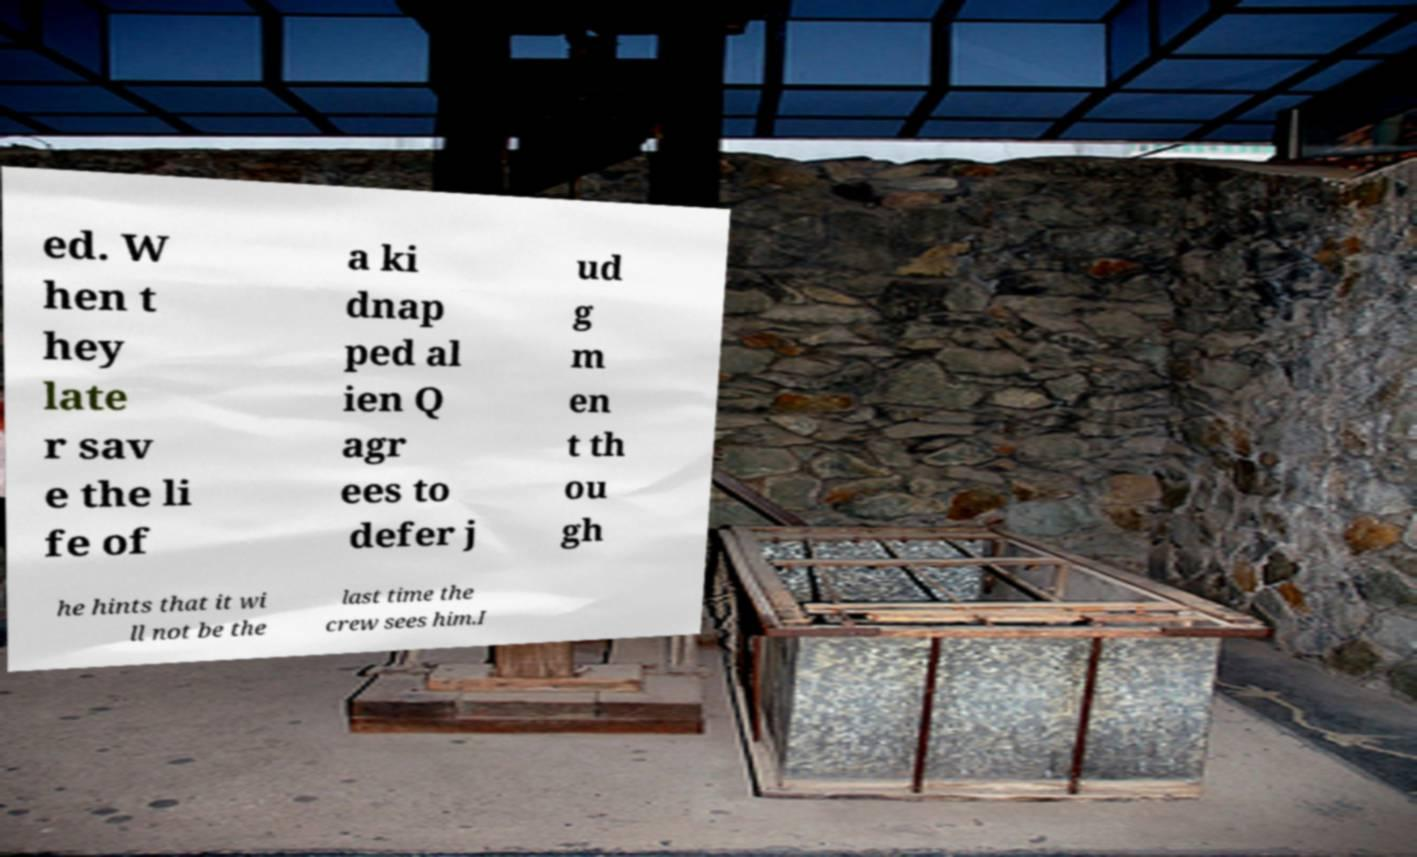Can you read and provide the text displayed in the image?This photo seems to have some interesting text. Can you extract and type it out for me? ed. W hen t hey late r sav e the li fe of a ki dnap ped al ien Q agr ees to defer j ud g m en t th ou gh he hints that it wi ll not be the last time the crew sees him.I 